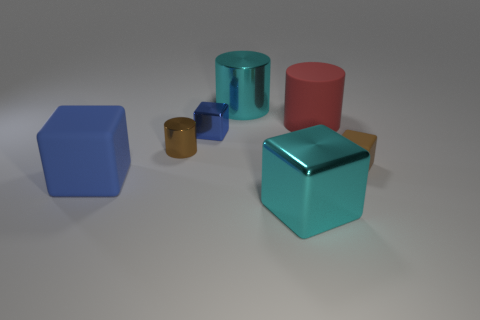Subtract all tiny cylinders. How many cylinders are left? 2 Add 1 large rubber cubes. How many objects exist? 8 Subtract all red cylinders. How many cylinders are left? 2 Subtract all cylinders. How many objects are left? 4 Subtract 1 cylinders. How many cylinders are left? 2 Subtract all blue balls. How many brown cylinders are left? 1 Subtract all large red cylinders. Subtract all red cylinders. How many objects are left? 5 Add 1 large cyan cylinders. How many large cyan cylinders are left? 2 Add 6 large gray things. How many large gray things exist? 6 Subtract 1 brown blocks. How many objects are left? 6 